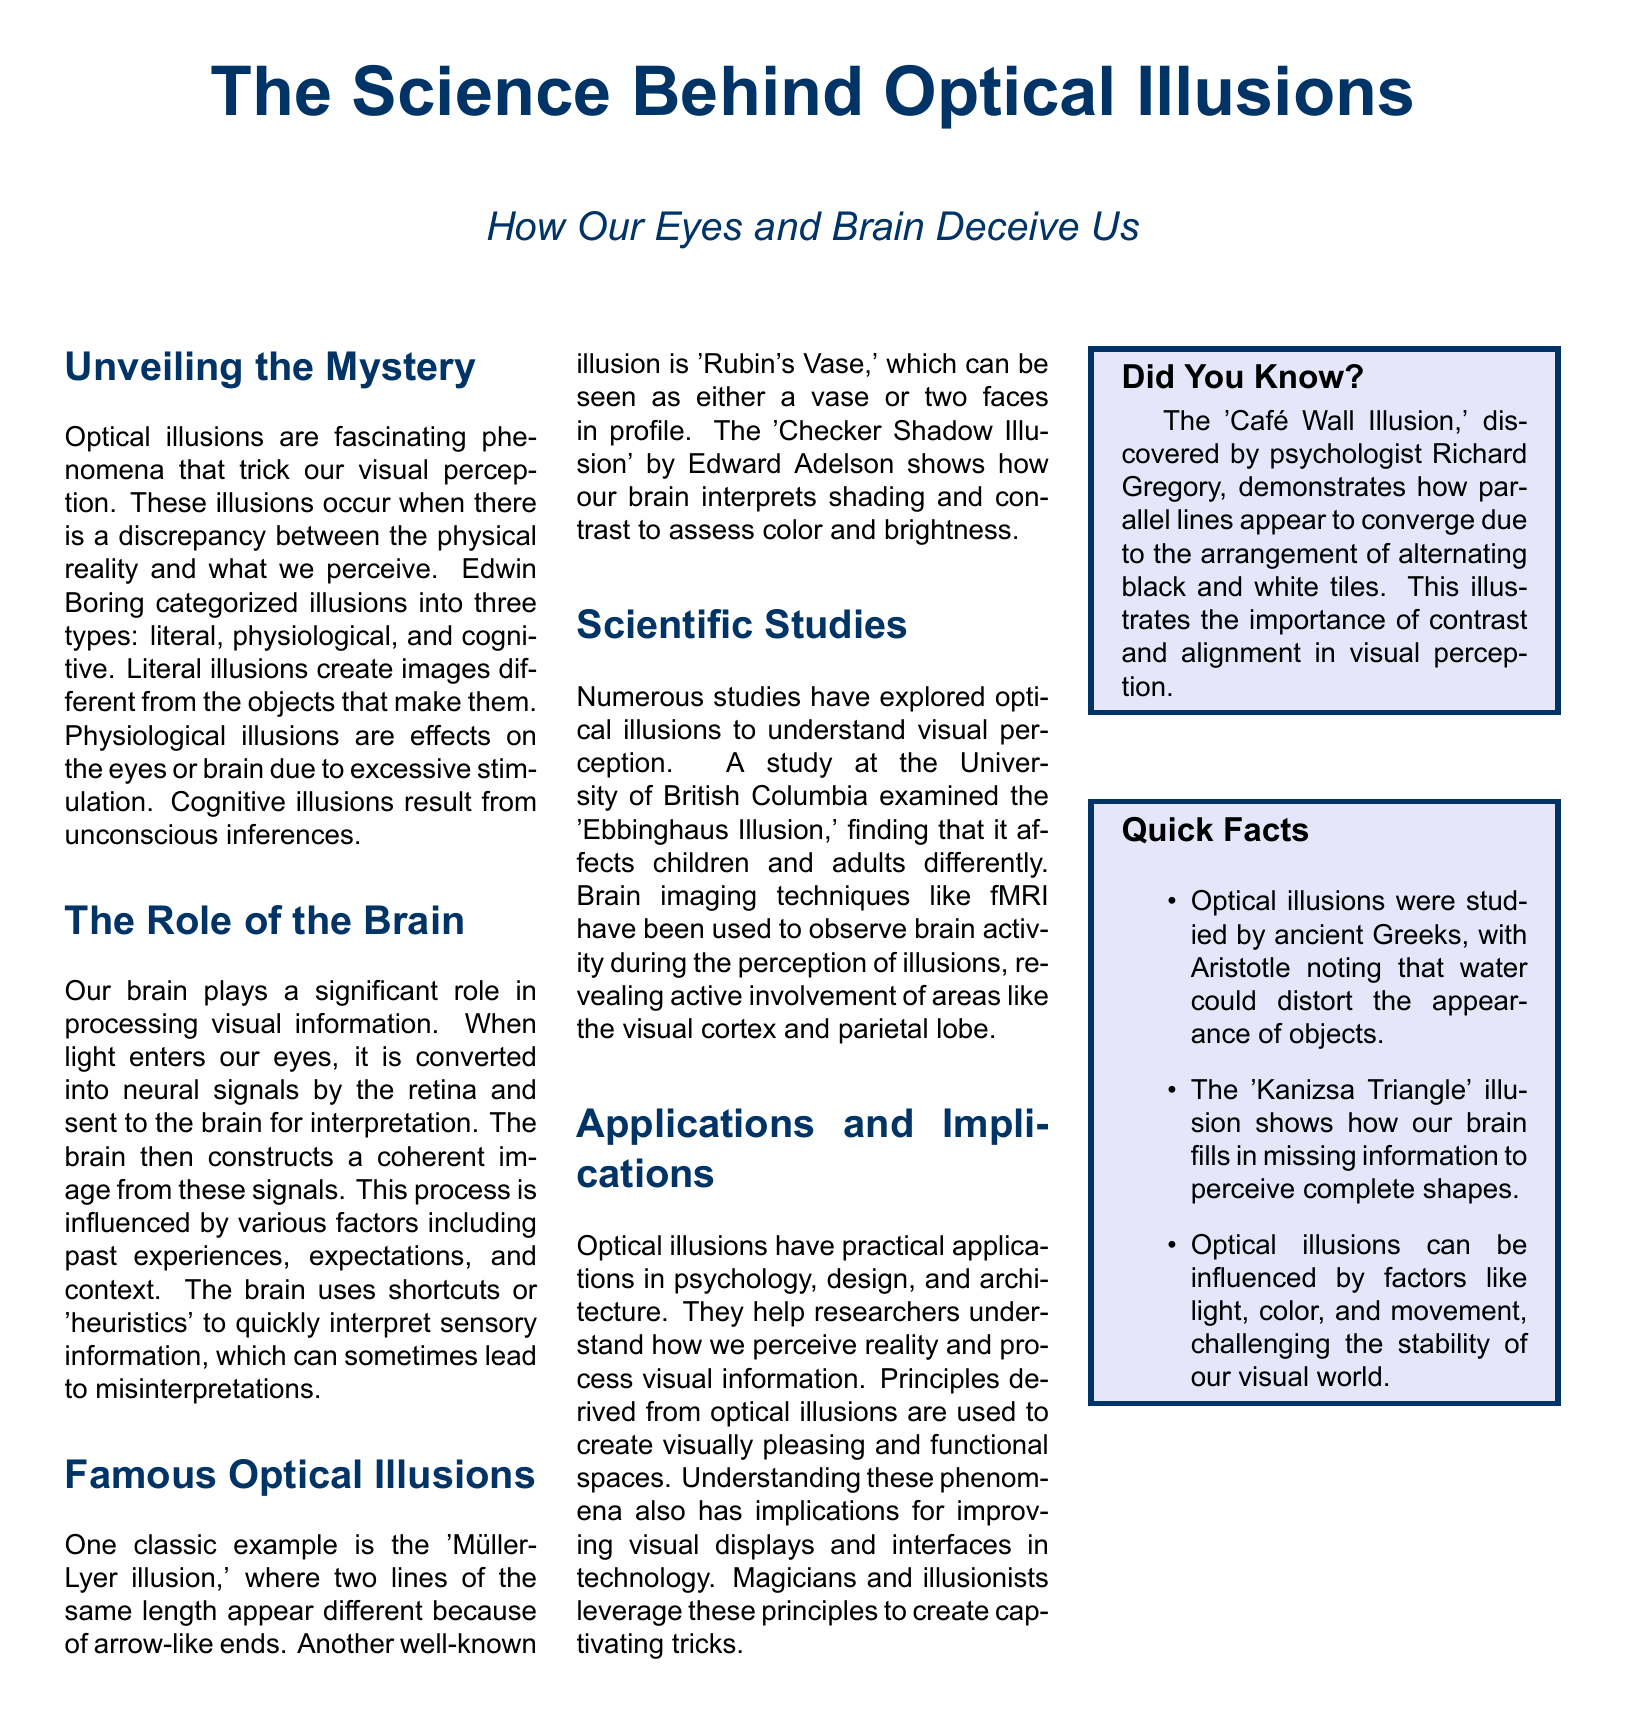What are the three types of optical illusions? The document states that Edwin Boring categorized illusions into three types: literal, physiological, and cognitive.
Answer: literal, physiological, cognitive Who discovered the 'Café Wall Illusion'? The document mentions that the 'Café Wall Illusion' was discovered by psychologist Richard Gregory.
Answer: Richard Gregory Which illusion shows two lines of the same length appearing different? The 'Müller-Lyer illusion' is mentioned as an example of this phenomenon in the document.
Answer: Müller-Lyer illusion What is the significance of the brain's shortcuts in interpreting visual information? The document explains that the brain uses shortcuts or 'heuristics' to quickly interpret sensory information, which can sometimes lead to misinterpretations.
Answer: misinterpretations What study was conducted at the University of British Columbia? The document refers to a study examining the 'Ebbinghaus Illusion' and its effects on children and adults.
Answer: Ebbinghaus Illusion What are the areas of the brain involved in the perception of illusions? The document indicates that areas like the visual cortex and parietal lobe are actively involved during the perception of illusions.
Answer: visual cortex and parietal lobe How can optical illusions be applied in design and architecture? The document states that principles derived from optical illusions help create visually pleasing and functional spaces.
Answer: visually pleasing and functional spaces What is the 'Kanizsa Triangle' illusion? The document describes it as an illusion that shows how our brain fills in missing information to perceive complete shapes.
Answer: fills in missing information In which context were optical illusions studied by ancient Greeks? The document mentions that ancient Greeks studied optical illusions, with Aristotle noting water could distort the appearance of objects.
Answer: water distortion 